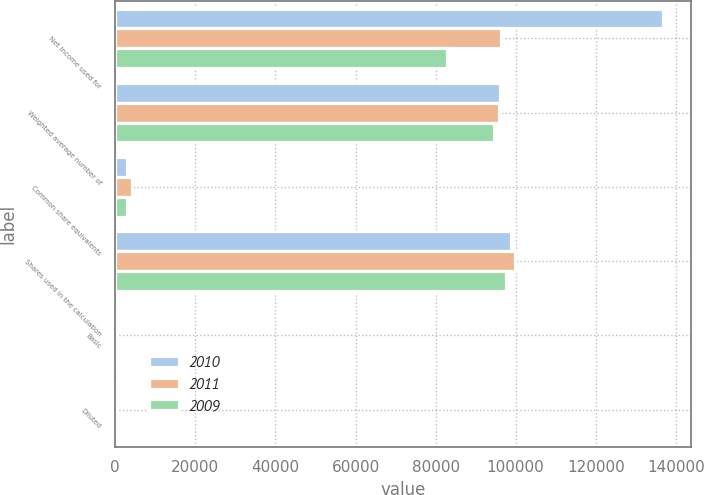Convert chart. <chart><loc_0><loc_0><loc_500><loc_500><stacked_bar_chart><ecel><fcel>Net income used for<fcel>Weighted average number of<fcel>Common share equivalents<fcel>Shares used in the calculation<fcel>Basic<fcel>Diluted<nl><fcel>2010<fcel>136902<fcel>96019<fcel>2827<fcel>98846<fcel>1.43<fcel>1.39<nl><fcel>2011<fcel>96285<fcel>95747<fcel>4087<fcel>99834<fcel>1.01<fcel>0.96<nl><fcel>2009<fcel>82964<fcel>94658<fcel>2891<fcel>97549<fcel>0.88<fcel>0.85<nl></chart> 